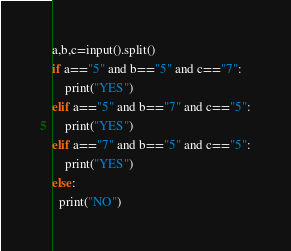Convert code to text. <code><loc_0><loc_0><loc_500><loc_500><_Python_>a,b,c=input().split()
if a=="5" and b=="5" and c=="7":
	print("YES")
elif a=="5" and b=="7" and c=="5":
	print("YES")
elif a=="7" and b=="5" and c=="5":
	print("YES")
else:
  print("NO")</code> 